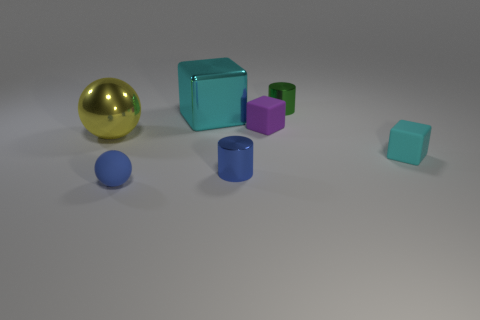Which two objects in the image seem the most reflective? The golden sphere and the large blue-green block appear to be the most reflective objects in this image, as indicated by the clear highlights on their surfaces that suggest a shiny material. 